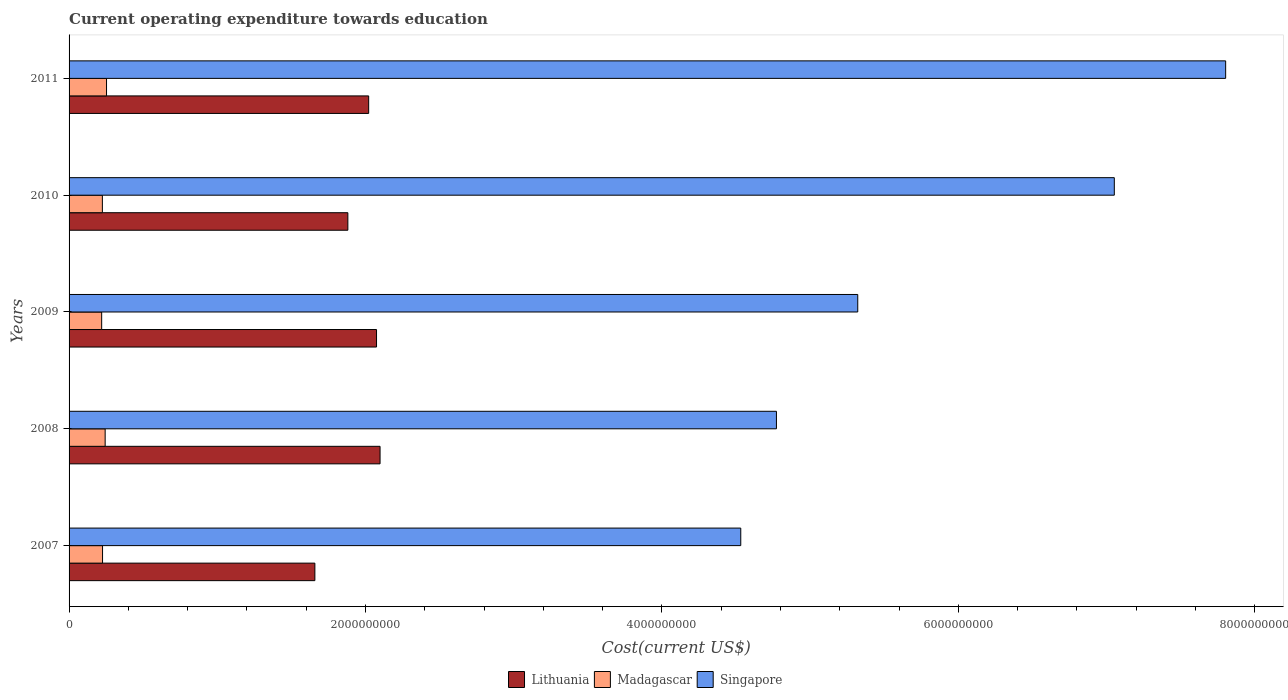How many groups of bars are there?
Your answer should be compact. 5. Are the number of bars per tick equal to the number of legend labels?
Provide a succinct answer. Yes. How many bars are there on the 5th tick from the top?
Make the answer very short. 3. How many bars are there on the 2nd tick from the bottom?
Your answer should be very brief. 3. What is the label of the 2nd group of bars from the top?
Offer a very short reply. 2010. In how many cases, is the number of bars for a given year not equal to the number of legend labels?
Provide a succinct answer. 0. What is the expenditure towards education in Lithuania in 2008?
Offer a terse response. 2.10e+09. Across all years, what is the maximum expenditure towards education in Madagascar?
Your answer should be very brief. 2.53e+08. Across all years, what is the minimum expenditure towards education in Lithuania?
Your response must be concise. 1.66e+09. In which year was the expenditure towards education in Madagascar minimum?
Provide a succinct answer. 2009. What is the total expenditure towards education in Madagascar in the graph?
Make the answer very short. 1.17e+09. What is the difference between the expenditure towards education in Lithuania in 2010 and that in 2011?
Provide a succinct answer. -1.40e+08. What is the difference between the expenditure towards education in Singapore in 2010 and the expenditure towards education in Madagascar in 2007?
Keep it short and to the point. 6.83e+09. What is the average expenditure towards education in Lithuania per year?
Offer a terse response. 1.95e+09. In the year 2007, what is the difference between the expenditure towards education in Lithuania and expenditure towards education in Madagascar?
Give a very brief answer. 1.43e+09. In how many years, is the expenditure towards education in Lithuania greater than 2800000000 US$?
Make the answer very short. 0. What is the ratio of the expenditure towards education in Lithuania in 2009 to that in 2011?
Your answer should be very brief. 1.03. Is the expenditure towards education in Singapore in 2007 less than that in 2009?
Your response must be concise. Yes. What is the difference between the highest and the second highest expenditure towards education in Madagascar?
Your response must be concise. 9.28e+06. What is the difference between the highest and the lowest expenditure towards education in Lithuania?
Provide a succinct answer. 4.40e+08. In how many years, is the expenditure towards education in Lithuania greater than the average expenditure towards education in Lithuania taken over all years?
Provide a short and direct response. 3. What does the 2nd bar from the top in 2011 represents?
Provide a short and direct response. Madagascar. What does the 1st bar from the bottom in 2011 represents?
Make the answer very short. Lithuania. Is it the case that in every year, the sum of the expenditure towards education in Lithuania and expenditure towards education in Madagascar is greater than the expenditure towards education in Singapore?
Offer a terse response. No. Are all the bars in the graph horizontal?
Ensure brevity in your answer.  Yes. How many years are there in the graph?
Offer a terse response. 5. What is the difference between two consecutive major ticks on the X-axis?
Provide a succinct answer. 2.00e+09. Are the values on the major ticks of X-axis written in scientific E-notation?
Provide a short and direct response. No. Does the graph contain any zero values?
Your response must be concise. No. Where does the legend appear in the graph?
Give a very brief answer. Bottom center. How are the legend labels stacked?
Provide a succinct answer. Horizontal. What is the title of the graph?
Provide a succinct answer. Current operating expenditure towards education. Does "Tajikistan" appear as one of the legend labels in the graph?
Ensure brevity in your answer.  No. What is the label or title of the X-axis?
Provide a short and direct response. Cost(current US$). What is the Cost(current US$) of Lithuania in 2007?
Offer a terse response. 1.66e+09. What is the Cost(current US$) in Madagascar in 2007?
Your response must be concise. 2.26e+08. What is the Cost(current US$) of Singapore in 2007?
Offer a terse response. 4.53e+09. What is the Cost(current US$) of Lithuania in 2008?
Ensure brevity in your answer.  2.10e+09. What is the Cost(current US$) in Madagascar in 2008?
Your response must be concise. 2.43e+08. What is the Cost(current US$) of Singapore in 2008?
Make the answer very short. 4.77e+09. What is the Cost(current US$) in Lithuania in 2009?
Your answer should be compact. 2.07e+09. What is the Cost(current US$) in Madagascar in 2009?
Your response must be concise. 2.20e+08. What is the Cost(current US$) in Singapore in 2009?
Ensure brevity in your answer.  5.32e+09. What is the Cost(current US$) in Lithuania in 2010?
Make the answer very short. 1.88e+09. What is the Cost(current US$) in Madagascar in 2010?
Your answer should be compact. 2.25e+08. What is the Cost(current US$) of Singapore in 2010?
Provide a short and direct response. 7.05e+09. What is the Cost(current US$) in Lithuania in 2011?
Make the answer very short. 2.02e+09. What is the Cost(current US$) of Madagascar in 2011?
Ensure brevity in your answer.  2.53e+08. What is the Cost(current US$) of Singapore in 2011?
Give a very brief answer. 7.80e+09. Across all years, what is the maximum Cost(current US$) in Lithuania?
Your response must be concise. 2.10e+09. Across all years, what is the maximum Cost(current US$) of Madagascar?
Offer a very short reply. 2.53e+08. Across all years, what is the maximum Cost(current US$) in Singapore?
Ensure brevity in your answer.  7.80e+09. Across all years, what is the minimum Cost(current US$) of Lithuania?
Offer a terse response. 1.66e+09. Across all years, what is the minimum Cost(current US$) in Madagascar?
Give a very brief answer. 2.20e+08. Across all years, what is the minimum Cost(current US$) of Singapore?
Give a very brief answer. 4.53e+09. What is the total Cost(current US$) in Lithuania in the graph?
Offer a very short reply. 9.73e+09. What is the total Cost(current US$) in Madagascar in the graph?
Your answer should be very brief. 1.17e+09. What is the total Cost(current US$) in Singapore in the graph?
Provide a succinct answer. 2.95e+1. What is the difference between the Cost(current US$) in Lithuania in 2007 and that in 2008?
Provide a short and direct response. -4.40e+08. What is the difference between the Cost(current US$) in Madagascar in 2007 and that in 2008?
Keep it short and to the point. -1.75e+07. What is the difference between the Cost(current US$) of Singapore in 2007 and that in 2008?
Keep it short and to the point. -2.41e+08. What is the difference between the Cost(current US$) in Lithuania in 2007 and that in 2009?
Ensure brevity in your answer.  -4.16e+08. What is the difference between the Cost(current US$) of Madagascar in 2007 and that in 2009?
Provide a succinct answer. 5.95e+06. What is the difference between the Cost(current US$) in Singapore in 2007 and that in 2009?
Make the answer very short. -7.89e+08. What is the difference between the Cost(current US$) in Lithuania in 2007 and that in 2010?
Provide a succinct answer. -2.22e+08. What is the difference between the Cost(current US$) in Madagascar in 2007 and that in 2010?
Your answer should be very brief. 1.16e+06. What is the difference between the Cost(current US$) of Singapore in 2007 and that in 2010?
Your answer should be very brief. -2.52e+09. What is the difference between the Cost(current US$) in Lithuania in 2007 and that in 2011?
Ensure brevity in your answer.  -3.63e+08. What is the difference between the Cost(current US$) in Madagascar in 2007 and that in 2011?
Your answer should be very brief. -2.68e+07. What is the difference between the Cost(current US$) in Singapore in 2007 and that in 2011?
Keep it short and to the point. -3.27e+09. What is the difference between the Cost(current US$) in Lithuania in 2008 and that in 2009?
Your answer should be compact. 2.38e+07. What is the difference between the Cost(current US$) of Madagascar in 2008 and that in 2009?
Offer a very short reply. 2.35e+07. What is the difference between the Cost(current US$) in Singapore in 2008 and that in 2009?
Offer a very short reply. -5.49e+08. What is the difference between the Cost(current US$) of Lithuania in 2008 and that in 2010?
Your answer should be compact. 2.17e+08. What is the difference between the Cost(current US$) of Madagascar in 2008 and that in 2010?
Provide a short and direct response. 1.87e+07. What is the difference between the Cost(current US$) of Singapore in 2008 and that in 2010?
Offer a terse response. -2.28e+09. What is the difference between the Cost(current US$) of Lithuania in 2008 and that in 2011?
Offer a very short reply. 7.68e+07. What is the difference between the Cost(current US$) of Madagascar in 2008 and that in 2011?
Your answer should be compact. -9.28e+06. What is the difference between the Cost(current US$) in Singapore in 2008 and that in 2011?
Keep it short and to the point. -3.03e+09. What is the difference between the Cost(current US$) in Lithuania in 2009 and that in 2010?
Provide a short and direct response. 1.94e+08. What is the difference between the Cost(current US$) in Madagascar in 2009 and that in 2010?
Give a very brief answer. -4.79e+06. What is the difference between the Cost(current US$) in Singapore in 2009 and that in 2010?
Keep it short and to the point. -1.73e+09. What is the difference between the Cost(current US$) of Lithuania in 2009 and that in 2011?
Make the answer very short. 5.31e+07. What is the difference between the Cost(current US$) in Madagascar in 2009 and that in 2011?
Make the answer very short. -3.28e+07. What is the difference between the Cost(current US$) of Singapore in 2009 and that in 2011?
Make the answer very short. -2.48e+09. What is the difference between the Cost(current US$) in Lithuania in 2010 and that in 2011?
Provide a succinct answer. -1.40e+08. What is the difference between the Cost(current US$) of Madagascar in 2010 and that in 2011?
Your answer should be very brief. -2.80e+07. What is the difference between the Cost(current US$) of Singapore in 2010 and that in 2011?
Provide a succinct answer. -7.51e+08. What is the difference between the Cost(current US$) in Lithuania in 2007 and the Cost(current US$) in Madagascar in 2008?
Give a very brief answer. 1.42e+09. What is the difference between the Cost(current US$) in Lithuania in 2007 and the Cost(current US$) in Singapore in 2008?
Your response must be concise. -3.11e+09. What is the difference between the Cost(current US$) of Madagascar in 2007 and the Cost(current US$) of Singapore in 2008?
Offer a terse response. -4.55e+09. What is the difference between the Cost(current US$) of Lithuania in 2007 and the Cost(current US$) of Madagascar in 2009?
Offer a terse response. 1.44e+09. What is the difference between the Cost(current US$) of Lithuania in 2007 and the Cost(current US$) of Singapore in 2009?
Provide a short and direct response. -3.66e+09. What is the difference between the Cost(current US$) of Madagascar in 2007 and the Cost(current US$) of Singapore in 2009?
Offer a terse response. -5.10e+09. What is the difference between the Cost(current US$) in Lithuania in 2007 and the Cost(current US$) in Madagascar in 2010?
Your answer should be very brief. 1.43e+09. What is the difference between the Cost(current US$) in Lithuania in 2007 and the Cost(current US$) in Singapore in 2010?
Your answer should be very brief. -5.39e+09. What is the difference between the Cost(current US$) in Madagascar in 2007 and the Cost(current US$) in Singapore in 2010?
Make the answer very short. -6.83e+09. What is the difference between the Cost(current US$) in Lithuania in 2007 and the Cost(current US$) in Madagascar in 2011?
Provide a short and direct response. 1.41e+09. What is the difference between the Cost(current US$) of Lithuania in 2007 and the Cost(current US$) of Singapore in 2011?
Your answer should be very brief. -6.15e+09. What is the difference between the Cost(current US$) of Madagascar in 2007 and the Cost(current US$) of Singapore in 2011?
Provide a succinct answer. -7.58e+09. What is the difference between the Cost(current US$) in Lithuania in 2008 and the Cost(current US$) in Madagascar in 2009?
Keep it short and to the point. 1.88e+09. What is the difference between the Cost(current US$) in Lithuania in 2008 and the Cost(current US$) in Singapore in 2009?
Give a very brief answer. -3.22e+09. What is the difference between the Cost(current US$) of Madagascar in 2008 and the Cost(current US$) of Singapore in 2009?
Keep it short and to the point. -5.08e+09. What is the difference between the Cost(current US$) of Lithuania in 2008 and the Cost(current US$) of Madagascar in 2010?
Your answer should be very brief. 1.87e+09. What is the difference between the Cost(current US$) in Lithuania in 2008 and the Cost(current US$) in Singapore in 2010?
Offer a very short reply. -4.95e+09. What is the difference between the Cost(current US$) in Madagascar in 2008 and the Cost(current US$) in Singapore in 2010?
Your answer should be compact. -6.81e+09. What is the difference between the Cost(current US$) in Lithuania in 2008 and the Cost(current US$) in Madagascar in 2011?
Ensure brevity in your answer.  1.85e+09. What is the difference between the Cost(current US$) of Lithuania in 2008 and the Cost(current US$) of Singapore in 2011?
Make the answer very short. -5.71e+09. What is the difference between the Cost(current US$) of Madagascar in 2008 and the Cost(current US$) of Singapore in 2011?
Give a very brief answer. -7.56e+09. What is the difference between the Cost(current US$) of Lithuania in 2009 and the Cost(current US$) of Madagascar in 2010?
Provide a short and direct response. 1.85e+09. What is the difference between the Cost(current US$) in Lithuania in 2009 and the Cost(current US$) in Singapore in 2010?
Your answer should be compact. -4.98e+09. What is the difference between the Cost(current US$) of Madagascar in 2009 and the Cost(current US$) of Singapore in 2010?
Give a very brief answer. -6.83e+09. What is the difference between the Cost(current US$) in Lithuania in 2009 and the Cost(current US$) in Madagascar in 2011?
Provide a succinct answer. 1.82e+09. What is the difference between the Cost(current US$) in Lithuania in 2009 and the Cost(current US$) in Singapore in 2011?
Offer a very short reply. -5.73e+09. What is the difference between the Cost(current US$) in Madagascar in 2009 and the Cost(current US$) in Singapore in 2011?
Ensure brevity in your answer.  -7.58e+09. What is the difference between the Cost(current US$) of Lithuania in 2010 and the Cost(current US$) of Madagascar in 2011?
Provide a short and direct response. 1.63e+09. What is the difference between the Cost(current US$) of Lithuania in 2010 and the Cost(current US$) of Singapore in 2011?
Keep it short and to the point. -5.92e+09. What is the difference between the Cost(current US$) in Madagascar in 2010 and the Cost(current US$) in Singapore in 2011?
Keep it short and to the point. -7.58e+09. What is the average Cost(current US$) of Lithuania per year?
Give a very brief answer. 1.95e+09. What is the average Cost(current US$) of Madagascar per year?
Ensure brevity in your answer.  2.33e+08. What is the average Cost(current US$) of Singapore per year?
Offer a terse response. 5.90e+09. In the year 2007, what is the difference between the Cost(current US$) in Lithuania and Cost(current US$) in Madagascar?
Your response must be concise. 1.43e+09. In the year 2007, what is the difference between the Cost(current US$) in Lithuania and Cost(current US$) in Singapore?
Your response must be concise. -2.87e+09. In the year 2007, what is the difference between the Cost(current US$) of Madagascar and Cost(current US$) of Singapore?
Your answer should be compact. -4.31e+09. In the year 2008, what is the difference between the Cost(current US$) of Lithuania and Cost(current US$) of Madagascar?
Provide a succinct answer. 1.85e+09. In the year 2008, what is the difference between the Cost(current US$) in Lithuania and Cost(current US$) in Singapore?
Your answer should be compact. -2.67e+09. In the year 2008, what is the difference between the Cost(current US$) in Madagascar and Cost(current US$) in Singapore?
Give a very brief answer. -4.53e+09. In the year 2009, what is the difference between the Cost(current US$) of Lithuania and Cost(current US$) of Madagascar?
Your response must be concise. 1.85e+09. In the year 2009, what is the difference between the Cost(current US$) of Lithuania and Cost(current US$) of Singapore?
Offer a terse response. -3.25e+09. In the year 2009, what is the difference between the Cost(current US$) of Madagascar and Cost(current US$) of Singapore?
Provide a succinct answer. -5.10e+09. In the year 2010, what is the difference between the Cost(current US$) in Lithuania and Cost(current US$) in Madagascar?
Make the answer very short. 1.66e+09. In the year 2010, what is the difference between the Cost(current US$) in Lithuania and Cost(current US$) in Singapore?
Make the answer very short. -5.17e+09. In the year 2010, what is the difference between the Cost(current US$) in Madagascar and Cost(current US$) in Singapore?
Provide a short and direct response. -6.83e+09. In the year 2011, what is the difference between the Cost(current US$) in Lithuania and Cost(current US$) in Madagascar?
Your answer should be compact. 1.77e+09. In the year 2011, what is the difference between the Cost(current US$) in Lithuania and Cost(current US$) in Singapore?
Ensure brevity in your answer.  -5.78e+09. In the year 2011, what is the difference between the Cost(current US$) in Madagascar and Cost(current US$) in Singapore?
Your response must be concise. -7.55e+09. What is the ratio of the Cost(current US$) of Lithuania in 2007 to that in 2008?
Your answer should be very brief. 0.79. What is the ratio of the Cost(current US$) of Madagascar in 2007 to that in 2008?
Your response must be concise. 0.93. What is the ratio of the Cost(current US$) of Singapore in 2007 to that in 2008?
Your answer should be compact. 0.95. What is the ratio of the Cost(current US$) in Lithuania in 2007 to that in 2009?
Make the answer very short. 0.8. What is the ratio of the Cost(current US$) of Madagascar in 2007 to that in 2009?
Provide a succinct answer. 1.03. What is the ratio of the Cost(current US$) of Singapore in 2007 to that in 2009?
Your response must be concise. 0.85. What is the ratio of the Cost(current US$) of Lithuania in 2007 to that in 2010?
Your answer should be compact. 0.88. What is the ratio of the Cost(current US$) of Singapore in 2007 to that in 2010?
Keep it short and to the point. 0.64. What is the ratio of the Cost(current US$) in Lithuania in 2007 to that in 2011?
Provide a short and direct response. 0.82. What is the ratio of the Cost(current US$) in Madagascar in 2007 to that in 2011?
Give a very brief answer. 0.89. What is the ratio of the Cost(current US$) in Singapore in 2007 to that in 2011?
Make the answer very short. 0.58. What is the ratio of the Cost(current US$) in Lithuania in 2008 to that in 2009?
Ensure brevity in your answer.  1.01. What is the ratio of the Cost(current US$) of Madagascar in 2008 to that in 2009?
Ensure brevity in your answer.  1.11. What is the ratio of the Cost(current US$) in Singapore in 2008 to that in 2009?
Your response must be concise. 0.9. What is the ratio of the Cost(current US$) in Lithuania in 2008 to that in 2010?
Keep it short and to the point. 1.12. What is the ratio of the Cost(current US$) in Madagascar in 2008 to that in 2010?
Keep it short and to the point. 1.08. What is the ratio of the Cost(current US$) in Singapore in 2008 to that in 2010?
Your answer should be very brief. 0.68. What is the ratio of the Cost(current US$) in Lithuania in 2008 to that in 2011?
Make the answer very short. 1.04. What is the ratio of the Cost(current US$) of Madagascar in 2008 to that in 2011?
Keep it short and to the point. 0.96. What is the ratio of the Cost(current US$) in Singapore in 2008 to that in 2011?
Ensure brevity in your answer.  0.61. What is the ratio of the Cost(current US$) in Lithuania in 2009 to that in 2010?
Your answer should be compact. 1.1. What is the ratio of the Cost(current US$) of Madagascar in 2009 to that in 2010?
Ensure brevity in your answer.  0.98. What is the ratio of the Cost(current US$) of Singapore in 2009 to that in 2010?
Offer a very short reply. 0.75. What is the ratio of the Cost(current US$) of Lithuania in 2009 to that in 2011?
Your response must be concise. 1.03. What is the ratio of the Cost(current US$) in Madagascar in 2009 to that in 2011?
Give a very brief answer. 0.87. What is the ratio of the Cost(current US$) of Singapore in 2009 to that in 2011?
Offer a very short reply. 0.68. What is the ratio of the Cost(current US$) in Lithuania in 2010 to that in 2011?
Provide a succinct answer. 0.93. What is the ratio of the Cost(current US$) in Madagascar in 2010 to that in 2011?
Ensure brevity in your answer.  0.89. What is the ratio of the Cost(current US$) of Singapore in 2010 to that in 2011?
Keep it short and to the point. 0.9. What is the difference between the highest and the second highest Cost(current US$) in Lithuania?
Keep it short and to the point. 2.38e+07. What is the difference between the highest and the second highest Cost(current US$) of Madagascar?
Your response must be concise. 9.28e+06. What is the difference between the highest and the second highest Cost(current US$) in Singapore?
Your answer should be compact. 7.51e+08. What is the difference between the highest and the lowest Cost(current US$) in Lithuania?
Offer a terse response. 4.40e+08. What is the difference between the highest and the lowest Cost(current US$) in Madagascar?
Your response must be concise. 3.28e+07. What is the difference between the highest and the lowest Cost(current US$) in Singapore?
Provide a short and direct response. 3.27e+09. 